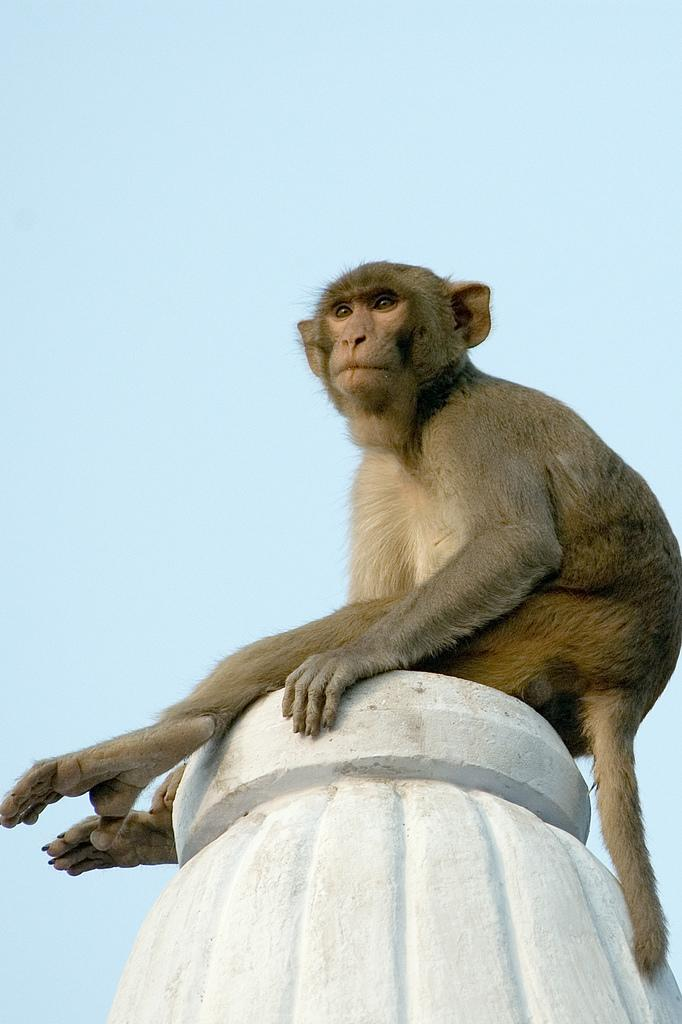What animal is present in the image? There is a monkey in the image. Where is the monkey located? The monkey is on a rock structure. What can be seen in the background of the image? There is sky visible in the background of the image. What type of belief is depicted in the image? There is no depiction of a belief in the image; it features a monkey on a rock structure with sky visible in the background. Is the monkey using a plough in the image? There is no plough present in the image; it only features a monkey on a rock structure with sky visible in the background. 